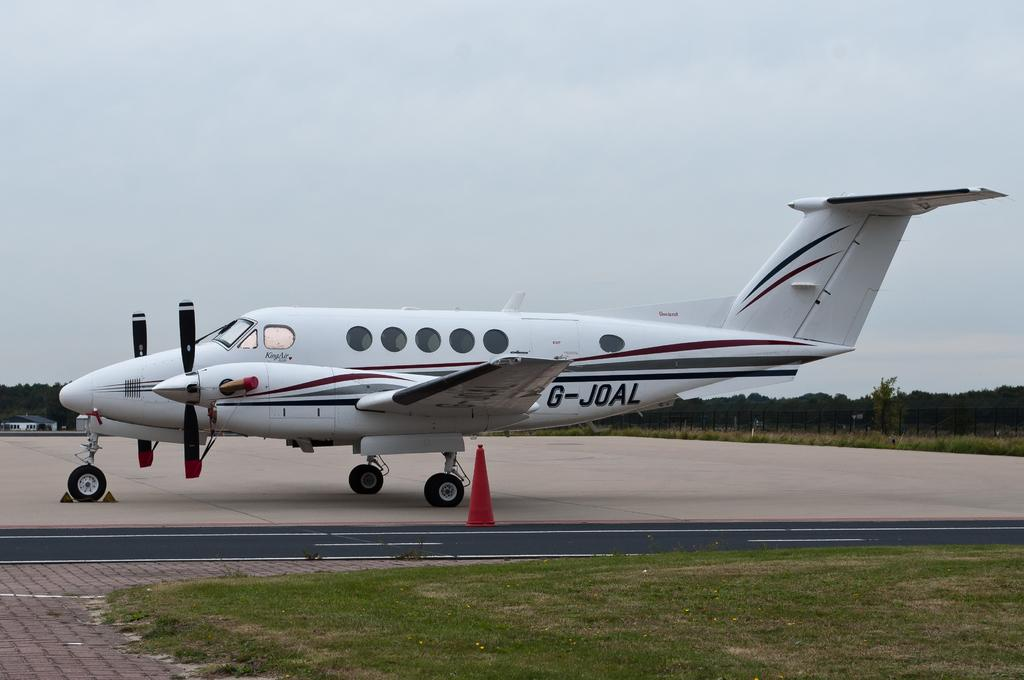<image>
Describe the image concisely. A red whit and black airplane sitting on a runway with G-joal on its side. 